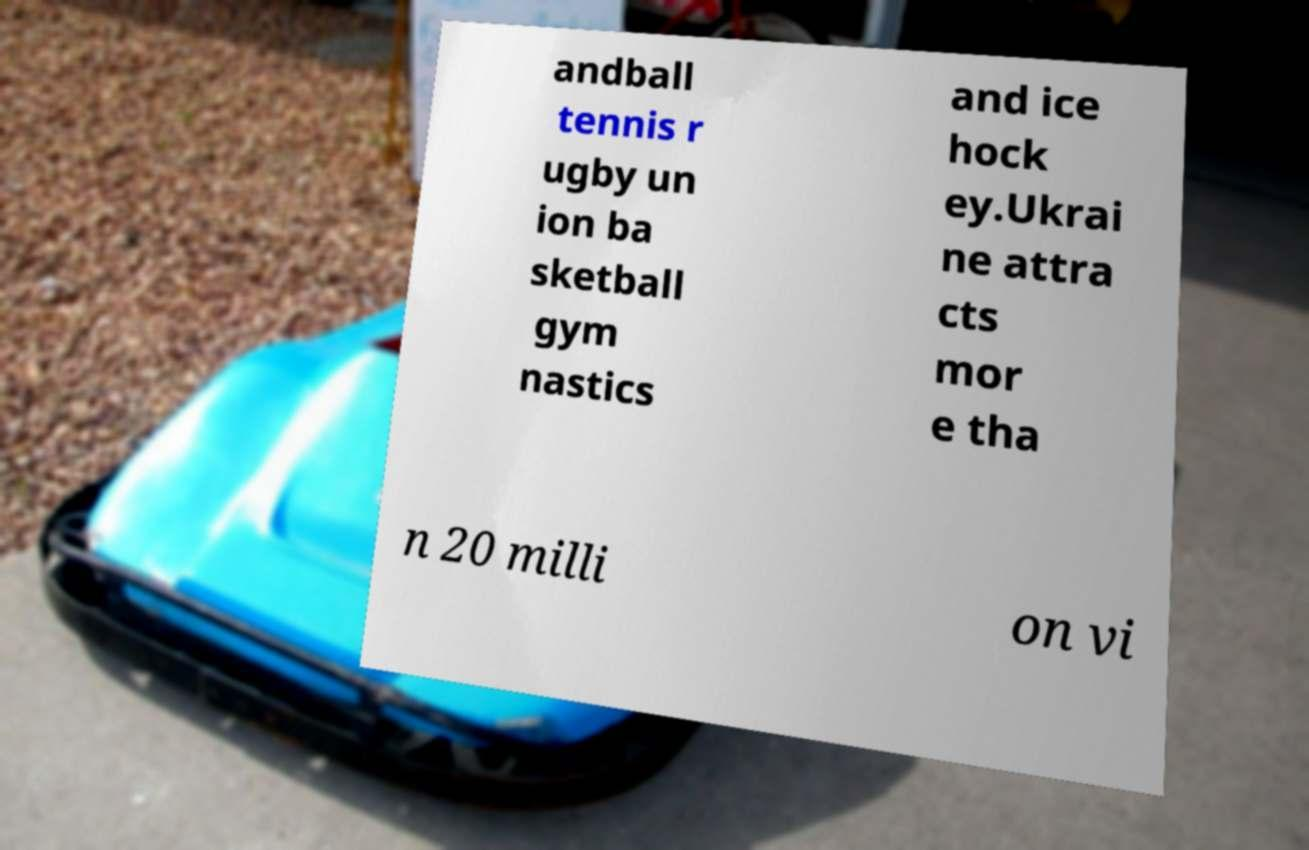Could you extract and type out the text from this image? andball tennis r ugby un ion ba sketball gym nastics and ice hock ey.Ukrai ne attra cts mor e tha n 20 milli on vi 